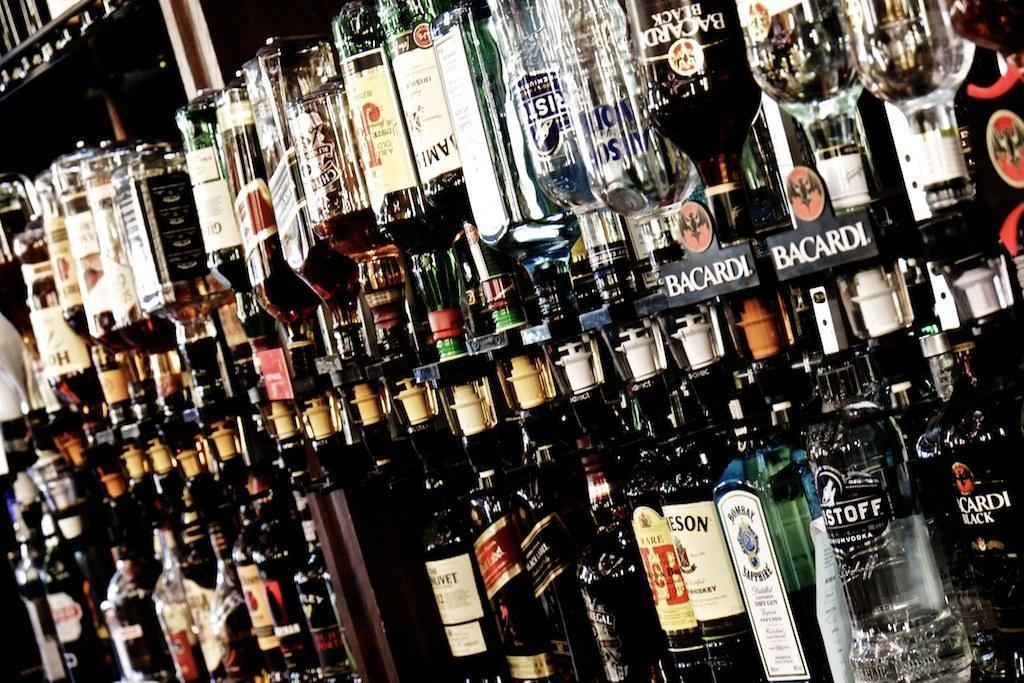In one or two sentences, can you explain what this image depicts? In this image, we can see so many bottles that are filled with liquid. In the middle, we can see some wooden pieces. 